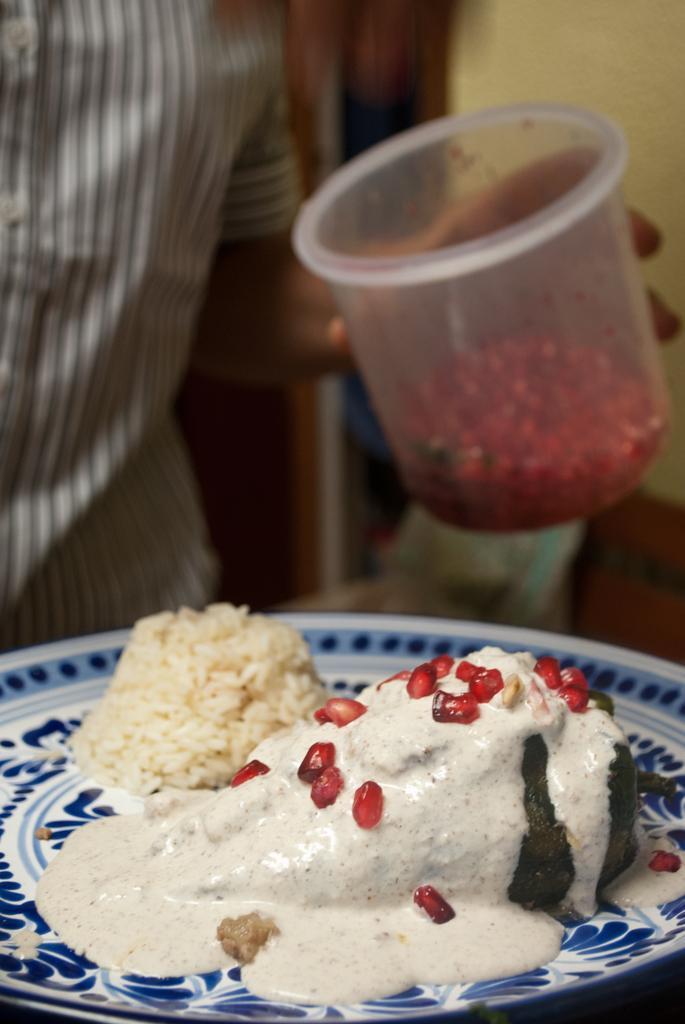How would you summarize this image in a sentence or two? At the bottom of the image we can see food in plate. In the background we can see person holding bowl and wall. 